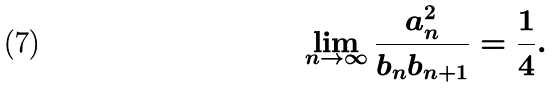<formula> <loc_0><loc_0><loc_500><loc_500>\lim _ { n \rightarrow \infty } \frac { a _ { n } ^ { 2 } } { b _ { n } b _ { n + 1 } } = \frac { 1 } { 4 } .</formula> 